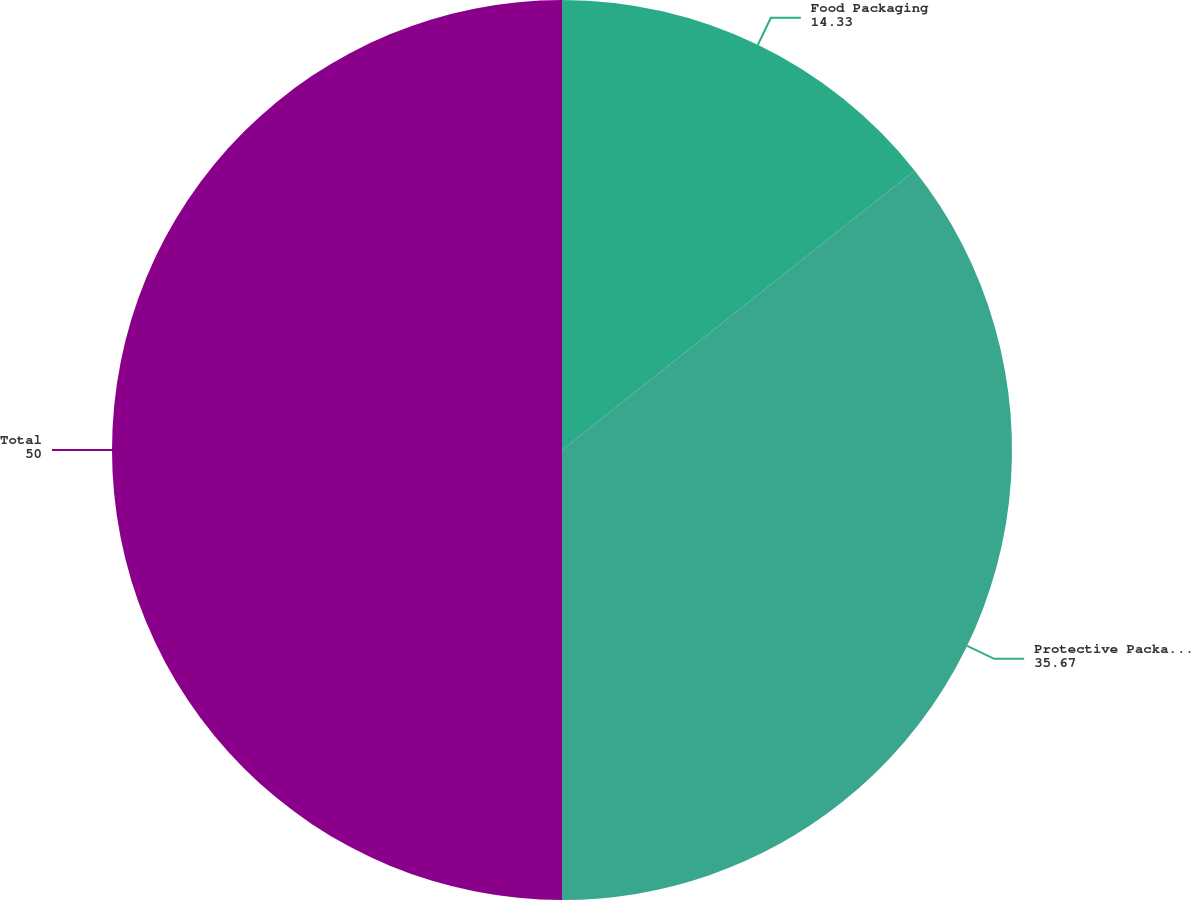Convert chart. <chart><loc_0><loc_0><loc_500><loc_500><pie_chart><fcel>Food Packaging<fcel>Protective Packaging<fcel>Total<nl><fcel>14.33%<fcel>35.67%<fcel>50.0%<nl></chart> 